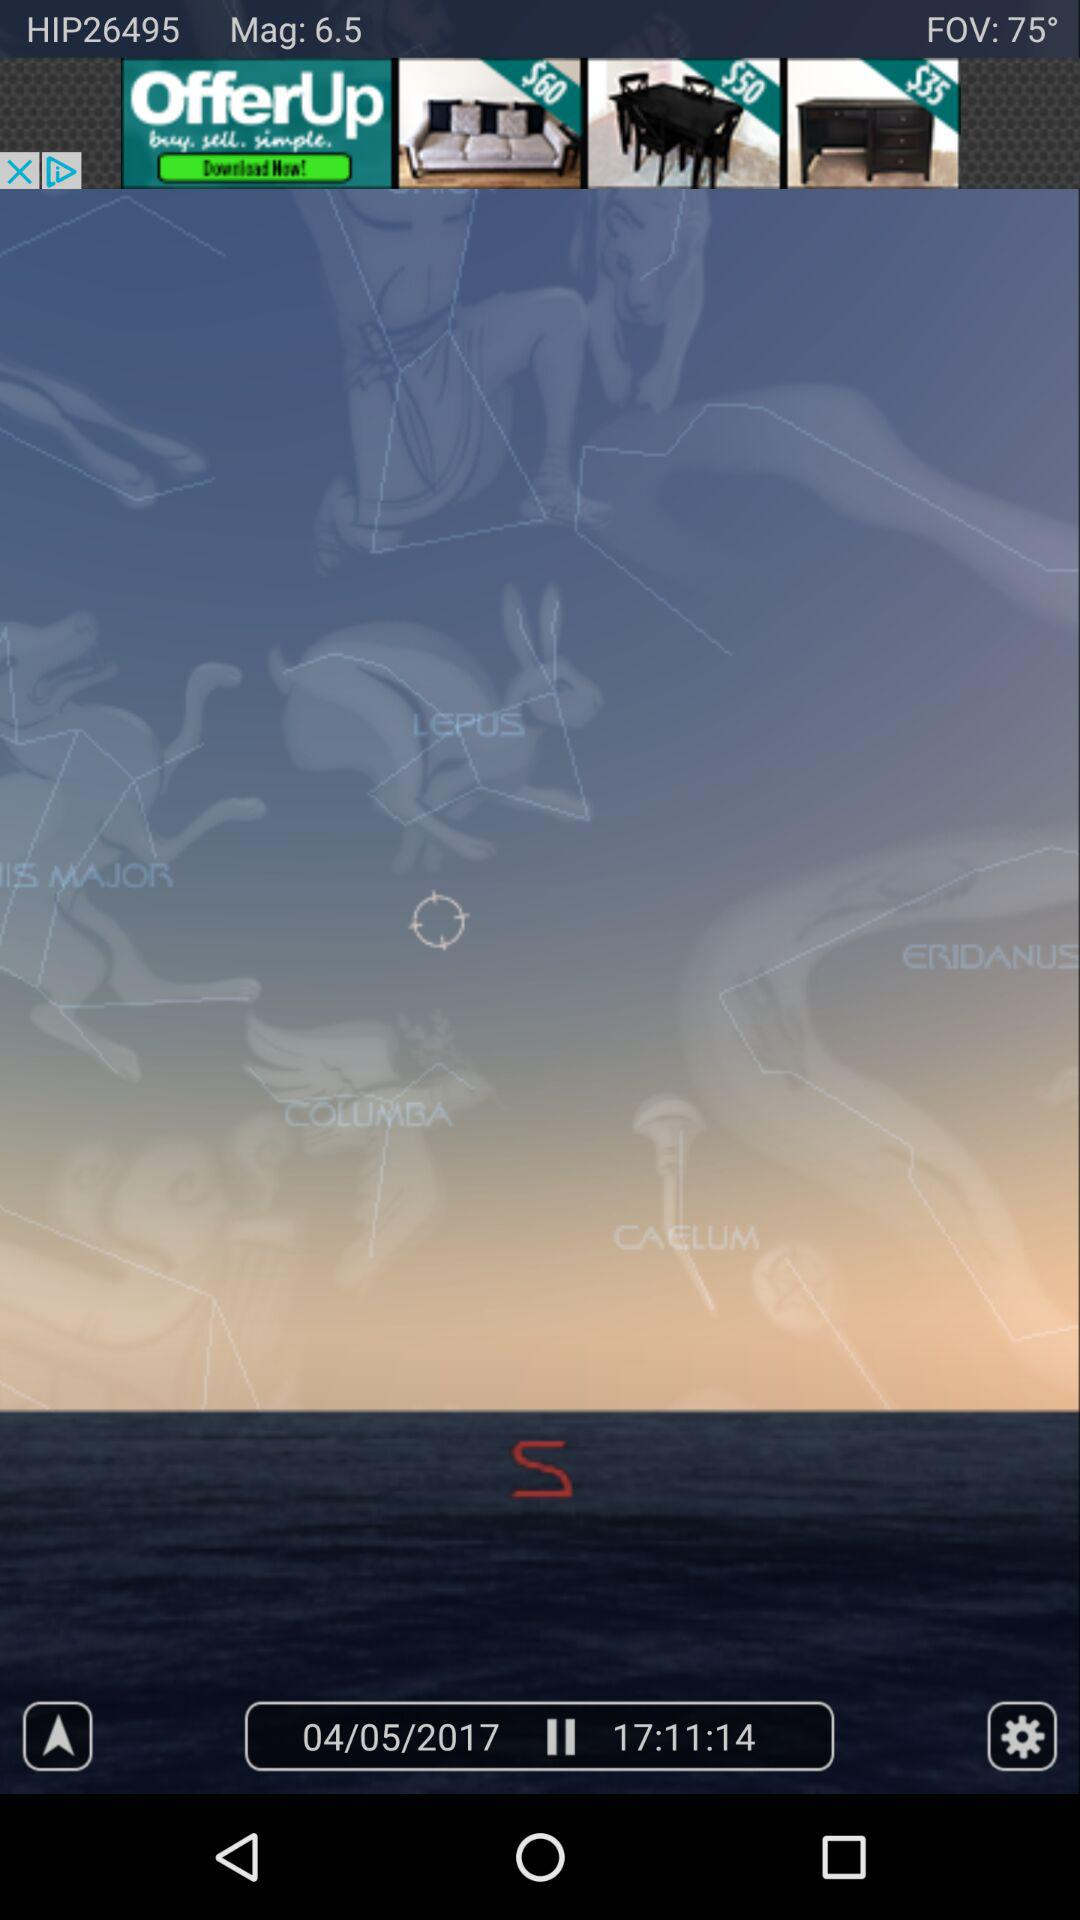What time is shown in the application? The shown time is 17:11:14. 